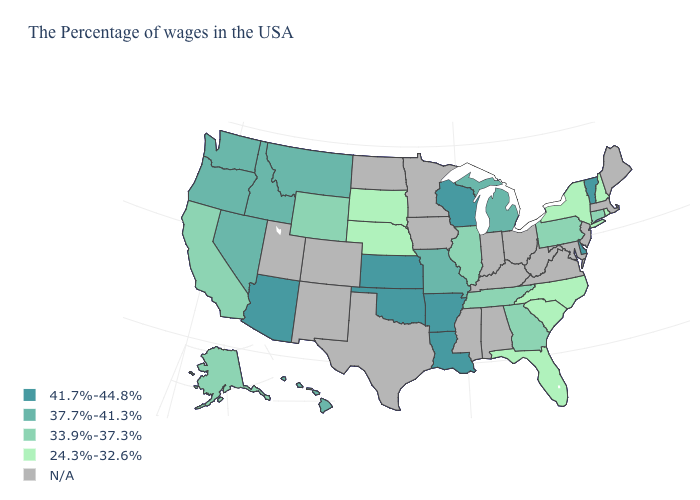What is the value of Wisconsin?
Quick response, please. 41.7%-44.8%. Is the legend a continuous bar?
Write a very short answer. No. What is the value of Delaware?
Answer briefly. 41.7%-44.8%. What is the lowest value in states that border Idaho?
Short answer required. 33.9%-37.3%. Does the map have missing data?
Answer briefly. Yes. Name the states that have a value in the range N/A?
Concise answer only. Maine, Massachusetts, New Jersey, Maryland, Virginia, West Virginia, Ohio, Kentucky, Indiana, Alabama, Mississippi, Minnesota, Iowa, Texas, North Dakota, Colorado, New Mexico, Utah. Name the states that have a value in the range 41.7%-44.8%?
Be succinct. Vermont, Delaware, Wisconsin, Louisiana, Arkansas, Kansas, Oklahoma, Arizona. Does South Carolina have the highest value in the USA?
Short answer required. No. Name the states that have a value in the range 37.7%-41.3%?
Keep it brief. Michigan, Missouri, Montana, Idaho, Nevada, Washington, Oregon, Hawaii. Name the states that have a value in the range 37.7%-41.3%?
Give a very brief answer. Michigan, Missouri, Montana, Idaho, Nevada, Washington, Oregon, Hawaii. Does Oklahoma have the highest value in the USA?
Keep it brief. Yes. Does Arizona have the highest value in the West?
Give a very brief answer. Yes. Name the states that have a value in the range 24.3%-32.6%?
Concise answer only. Rhode Island, New Hampshire, New York, North Carolina, South Carolina, Florida, Nebraska, South Dakota. What is the value of Kansas?
Be succinct. 41.7%-44.8%. 